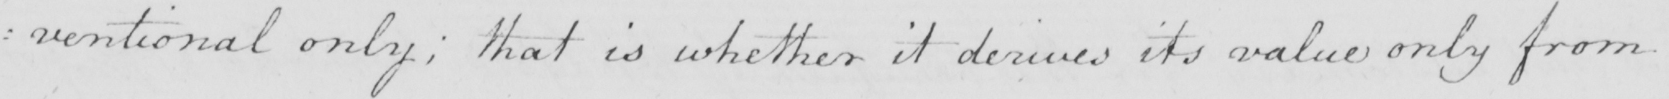What does this handwritten line say? : ventional only , that is whether it derives its value only from 